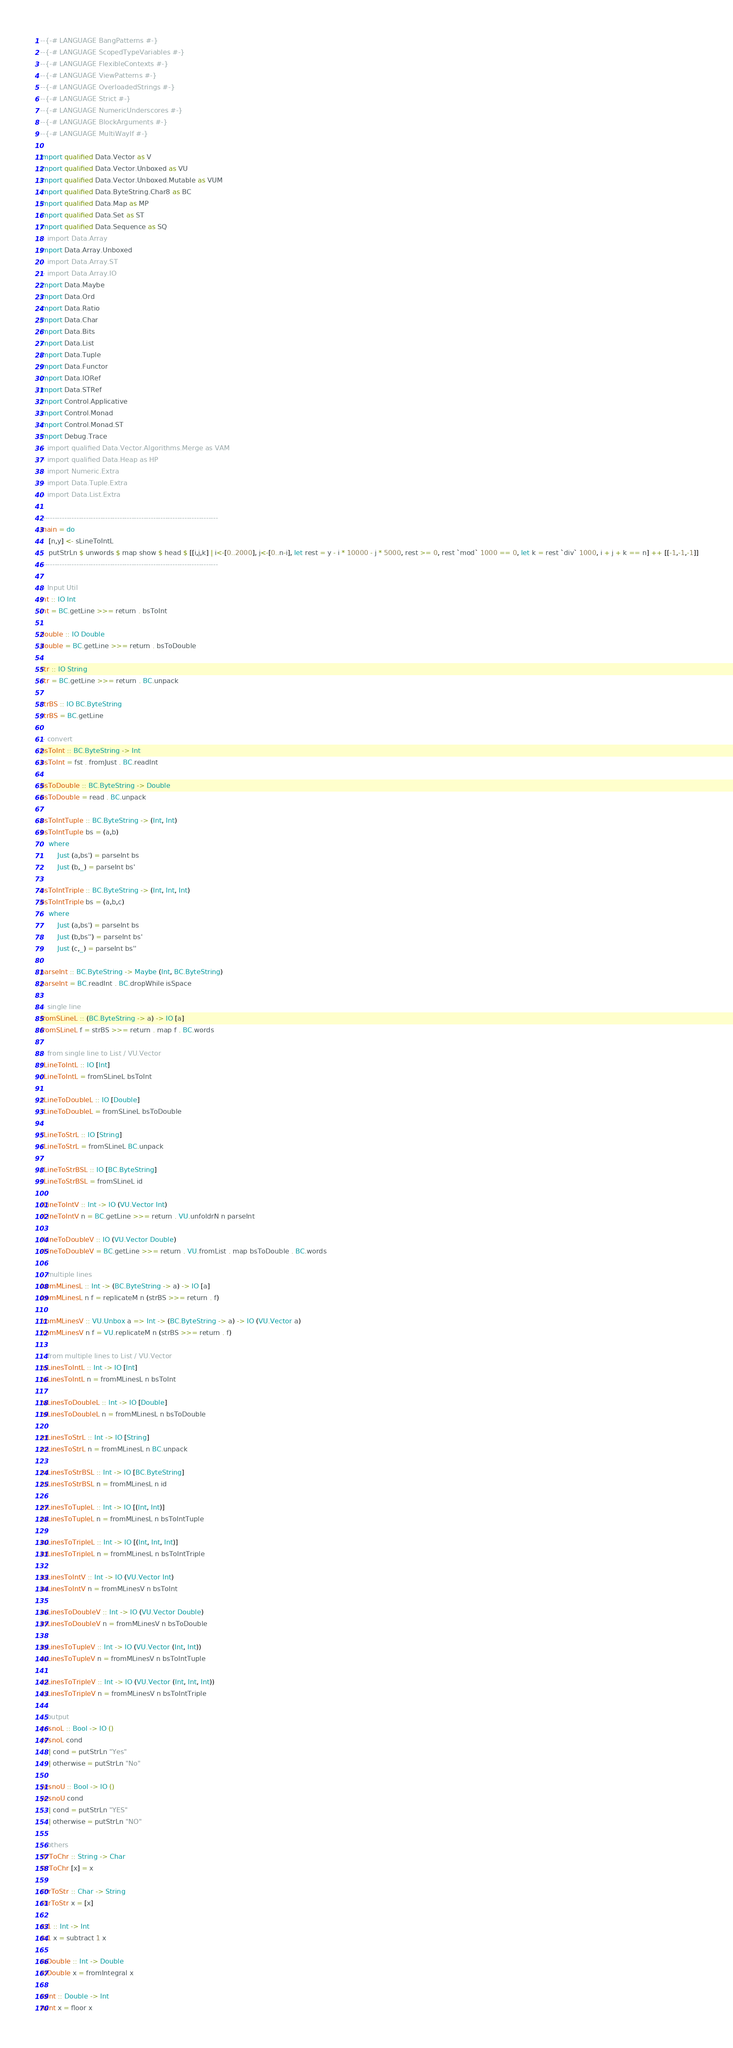<code> <loc_0><loc_0><loc_500><loc_500><_Haskell_>--{-# LANGUAGE BangPatterns #-}
--{-# LANGUAGE ScopedTypeVariables #-}
--{-# LANGUAGE FlexibleContexts #-}
--{-# LANGUAGE ViewPatterns #-}
--{-# LANGUAGE OverloadedStrings #-}
--{-# LANGUAGE Strict #-}
--{-# LANGUAGE NumericUnderscores #-}
--{-# LANGUAGE BlockArguments #-}
--{-# LANGUAGE MultiWayIf #-}

import qualified Data.Vector as V
import qualified Data.Vector.Unboxed as VU
import qualified Data.Vector.Unboxed.Mutable as VUM
import qualified Data.ByteString.Char8 as BC
import qualified Data.Map as MP
import qualified Data.Set as ST
import qualified Data.Sequence as SQ
-- import Data.Array
import Data.Array.Unboxed
-- import Data.Array.ST
-- import Data.Array.IO
import Data.Maybe
import Data.Ord
import Data.Ratio
import Data.Char
import Data.Bits
import Data.List
import Data.Tuple
import Data.Functor
import Data.IORef
import Data.STRef
import Control.Applicative
import Control.Monad
import Control.Monad.ST
import Debug.Trace
-- import qualified Data.Vector.Algorithms.Merge as VAM
-- import qualified Data.Heap as HP
-- import Numeric.Extra
-- import Data.Tuple.Extra
-- import Data.List.Extra

--------------------------------------------------------------------------
main = do
    [n,y] <- sLineToIntL
    putStrLn $ unwords $ map show $ head $ [[i,j,k] | i<-[0..2000], j<-[0..n-i], let rest = y - i * 10000 - j * 5000, rest >= 0, rest `mod` 1000 == 0, let k = rest `div` 1000, i + j + k == n] ++ [[-1,-1,-1]]
--------------------------------------------------------------------------

-- Input Util
int :: IO Int
int = BC.getLine >>= return . bsToInt

double :: IO Double
double = BC.getLine >>= return . bsToDouble

str :: IO String
str = BC.getLine >>= return . BC.unpack

strBS :: IO BC.ByteString
strBS = BC.getLine

-- convert
bsToInt :: BC.ByteString -> Int
bsToInt = fst . fromJust . BC.readInt

bsToDouble :: BC.ByteString -> Double
bsToDouble = read . BC.unpack

bsToIntTuple :: BC.ByteString -> (Int, Int)
bsToIntTuple bs = (a,b)
    where
        Just (a,bs') = parseInt bs
        Just (b,_) = parseInt bs'

bsToIntTriple :: BC.ByteString -> (Int, Int, Int)
bsToIntTriple bs = (a,b,c)
    where
        Just (a,bs') = parseInt bs
        Just (b,bs'') = parseInt bs'
        Just (c,_) = parseInt bs''

parseInt :: BC.ByteString -> Maybe (Int, BC.ByteString)
parseInt = BC.readInt . BC.dropWhile isSpace

-- single line
fromSLineL :: (BC.ByteString -> a) -> IO [a]
fromSLineL f = strBS >>= return . map f . BC.words

-- from single line to List / VU.Vector 
sLineToIntL :: IO [Int]
sLineToIntL = fromSLineL bsToInt

sLineToDoubleL :: IO [Double]
sLineToDoubleL = fromSLineL bsToDouble

sLineToStrL :: IO [String]
sLineToStrL = fromSLineL BC.unpack

sLineToStrBSL :: IO [BC.ByteString]
sLineToStrBSL = fromSLineL id 

sLineToIntV :: Int -> IO (VU.Vector Int)
sLineToIntV n = BC.getLine >>= return . VU.unfoldrN n parseInt

sLineToDoubleV :: IO (VU.Vector Double)
sLineToDoubleV = BC.getLine >>= return . VU.fromList . map bsToDouble . BC.words

-- multiple lines
fromMLinesL :: Int -> (BC.ByteString -> a) -> IO [a]
fromMLinesL n f = replicateM n (strBS >>= return . f)

fromMLinesV :: VU.Unbox a => Int -> (BC.ByteString -> a) -> IO (VU.Vector a)
fromMLinesV n f = VU.replicateM n (strBS >>= return . f)

-- from multiple lines to List / VU.Vector
mLinesToIntL :: Int -> IO [Int]
mLinesToIntL n = fromMLinesL n bsToInt

mLinesToDoubleL :: Int -> IO [Double]
mLinesToDoubleL n = fromMLinesL n bsToDouble

mLinesToStrL :: Int -> IO [String]
mLinesToStrL n = fromMLinesL n BC.unpack

mLinesToStrBSL :: Int -> IO [BC.ByteString]
mLinesToStrBSL n = fromMLinesL n id

mLinesToTupleL :: Int -> IO [(Int, Int)]
mLinesToTupleL n = fromMLinesL n bsToIntTuple

mLinesToTripleL :: Int -> IO [(Int, Int, Int)]
mLinesToTripleL n = fromMLinesL n bsToIntTriple

mLinesToIntV :: Int -> IO (VU.Vector Int)
mLinesToIntV n = fromMLinesV n bsToInt

mLinesToDoubleV :: Int -> IO (VU.Vector Double)
mLinesToDoubleV n = fromMLinesV n bsToDouble

mLinesToTupleV :: Int -> IO (VU.Vector (Int, Int))
mLinesToTupleV n = fromMLinesV n bsToIntTuple
    
mLinesToTripleV :: Int -> IO (VU.Vector (Int, Int, Int))
mLinesToTripleV n = fromMLinesV n bsToIntTriple

-- output
yesnoL :: Bool -> IO ()
yesnoL cond
    | cond = putStrLn "Yes"
    | otherwise = putStrLn "No"

yesnoU :: Bool -> IO ()
yesnoU cond
    | cond = putStrLn "YES"
    | otherwise = putStrLn "NO"

-- others
strToChr :: String -> Char
strToChr [x] = x

chrToStr :: Char -> String
chrToStr x = [x]

m1 :: Int -> Int
m1 x = subtract 1 x

toDouble :: Int -> Double
toDouble x = fromIntegral x

toInt :: Double -> Int
toInt x = floor x
</code> 